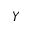Convert formula to latex. <formula><loc_0><loc_0><loc_500><loc_500>Y</formula> 